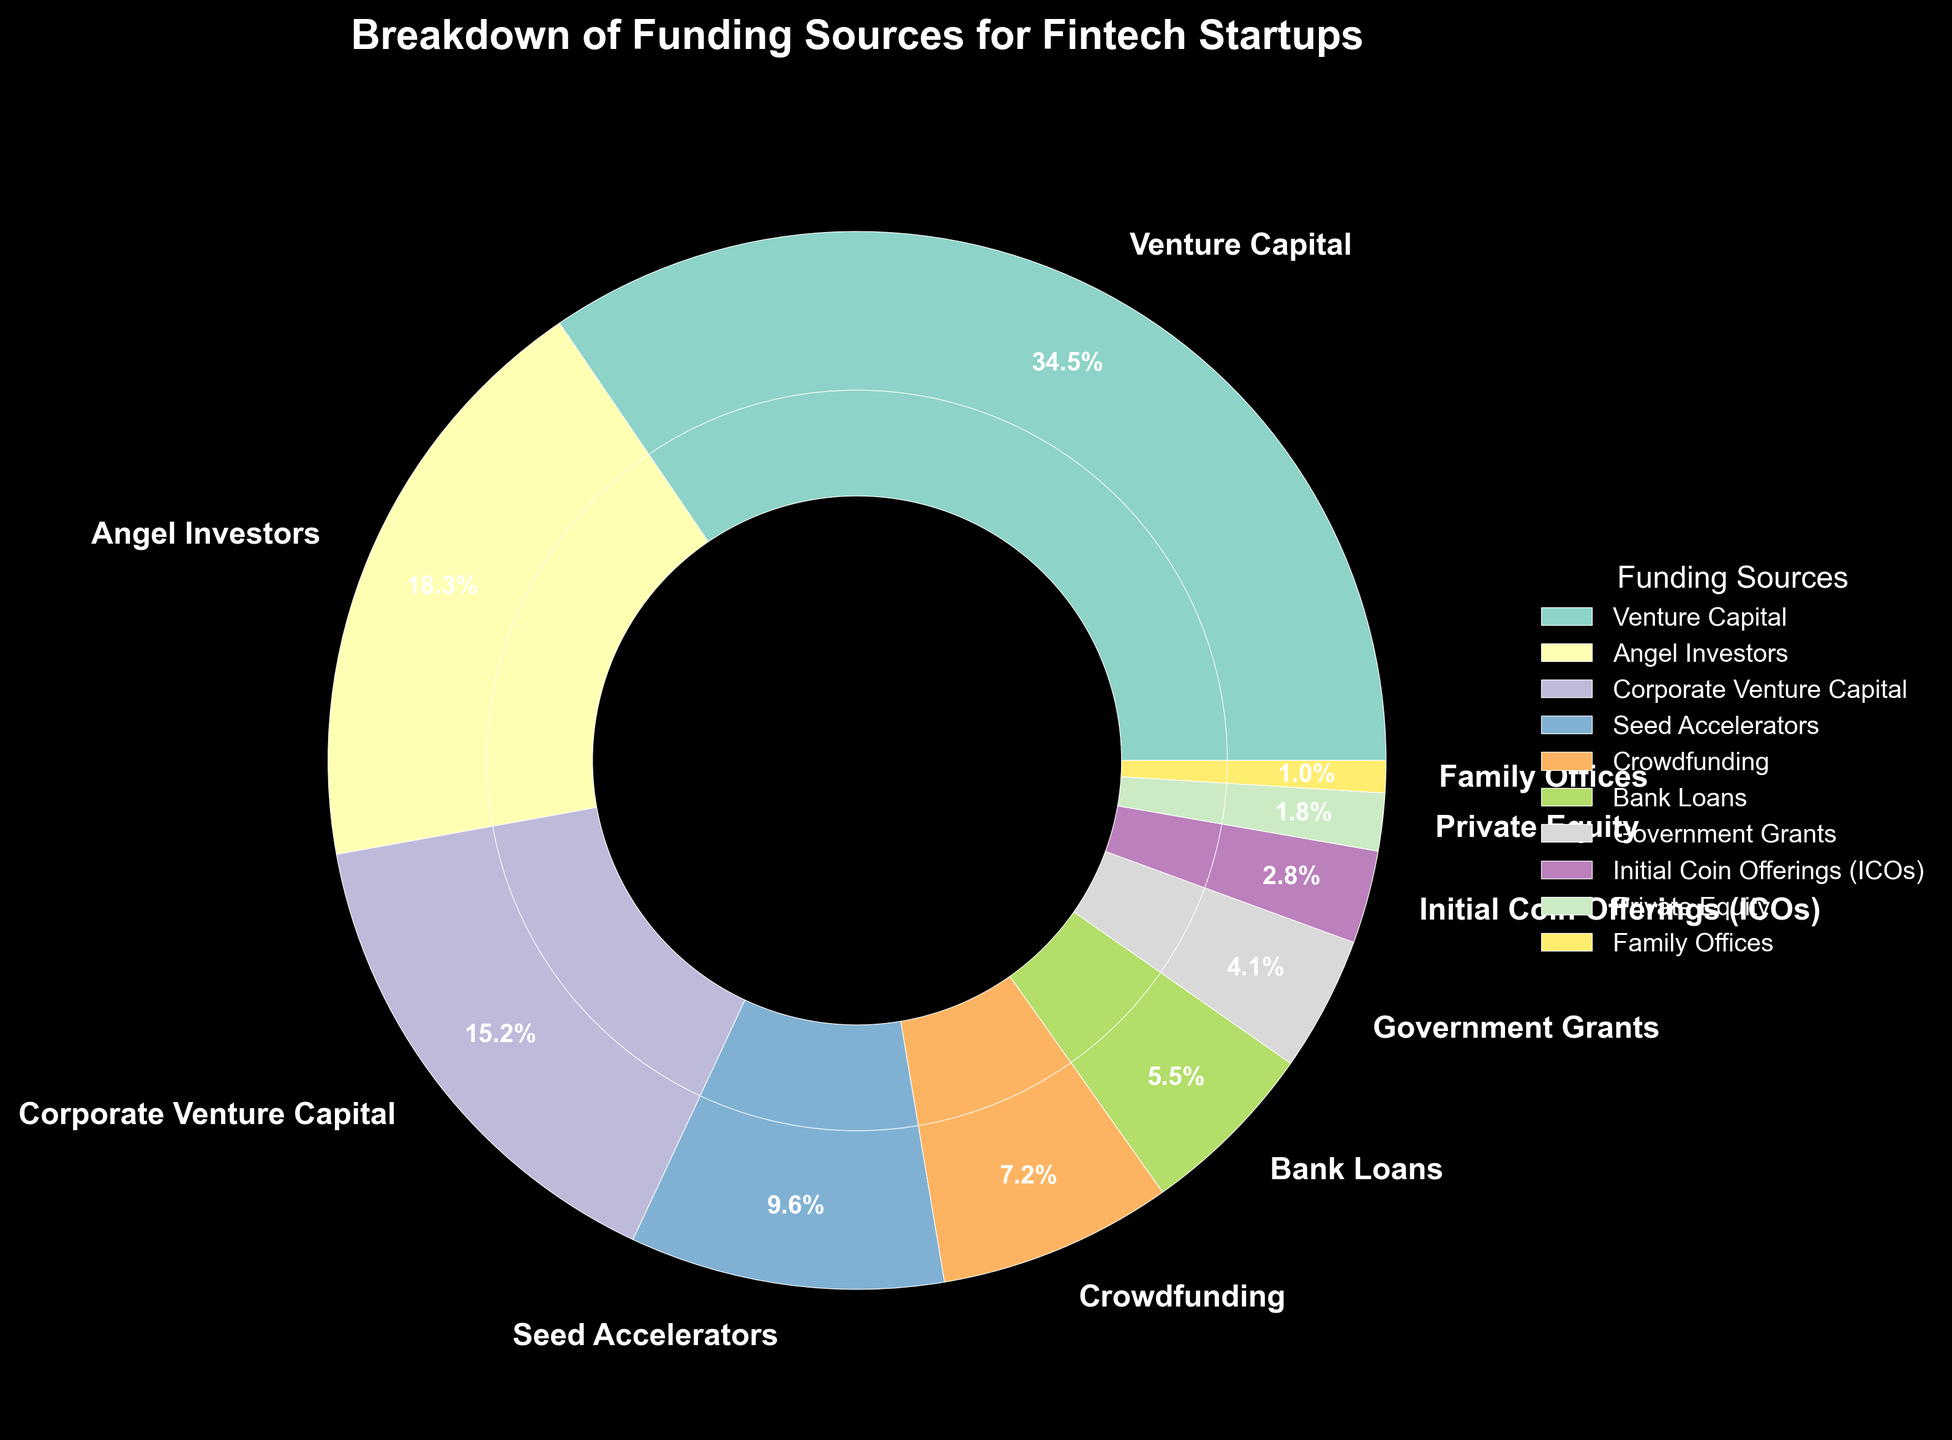What's the largest funding source for fintech startups? The largest segment by percentage indicates the largest funding source. From the pie chart, the "Venture Capital" segment is the largest with 35.2%.
Answer: Venture Capital Which funding sources contribute more than 15%? By visually observing the pie chart, we can identify the segments with percentages greater than 15%. "Venture Capital" (35.2%) and "Angel Investors" (18.7%) are above this threshold.
Answer: Venture Capital, Angel Investors What's the combined percentage of the smallest three funding sources? Identify the three smallest segments: "Family Offices" (1.0%), "Private Equity" (1.8%), and "Initial Coin Offerings (ICOs)" (2.9%). Sum their percentages: 1.0 + 1.8 + 2.9 = 5.7%.
Answer: 5.7% Are "Corporate Venture Capital" and "Seed Accelerators" together equivalent to or more than "Venture Capital"? Sum the percentages of "Corporate Venture Capital" (15.5%) and "Seed Accelerators" (9.8%) which is 15.5 + 9.8 = 25.3%. This is less than "Venture Capital" at 35.2%.
Answer: No What percentage difference exists between "Angel Investors" and "Crowdfunding"? Subtract the smaller percentage (Crowdfunding: 7.3%) from the larger percentage (Angel Investors: 18.7%): 18.7 - 7.3 = 11.4%.
Answer: 11.4% Which funding source has a percentage closest to 10%? Observing the pie chart, "Seed Accelerators" has a percentage of 9.8%, which is closest to 10%.
Answer: Seed Accelerators How does the percentage of "Government Grants" compare to "Bank Loans"? "Government Grants" is 4.2% and "Bank Loans" is 5.6%, so "Government Grants" is less than "Bank Loans".
Answer: Less Is the combined funding from "Crowdfunding" and "Government Grants" larger than "Seed Accelerators"? Sum "Crowdfunding" (7.3%) and "Government Grants" (4.2%): 7.3 + 4.2 = 11.5%. Compare this to "Seed Accelerators" (9.8%); 11.5% is larger.
Answer: Yes What is the contribution percentage of non-VC funding sources combined? All sources except "Venture Capital" must be summed: 18.7 + 15.5 + 9.8 + 7.3 + 5.6 + 4.2 + 2.9 + 1.8 + 1.0 = 66.1%.
Answer: 66.1% 